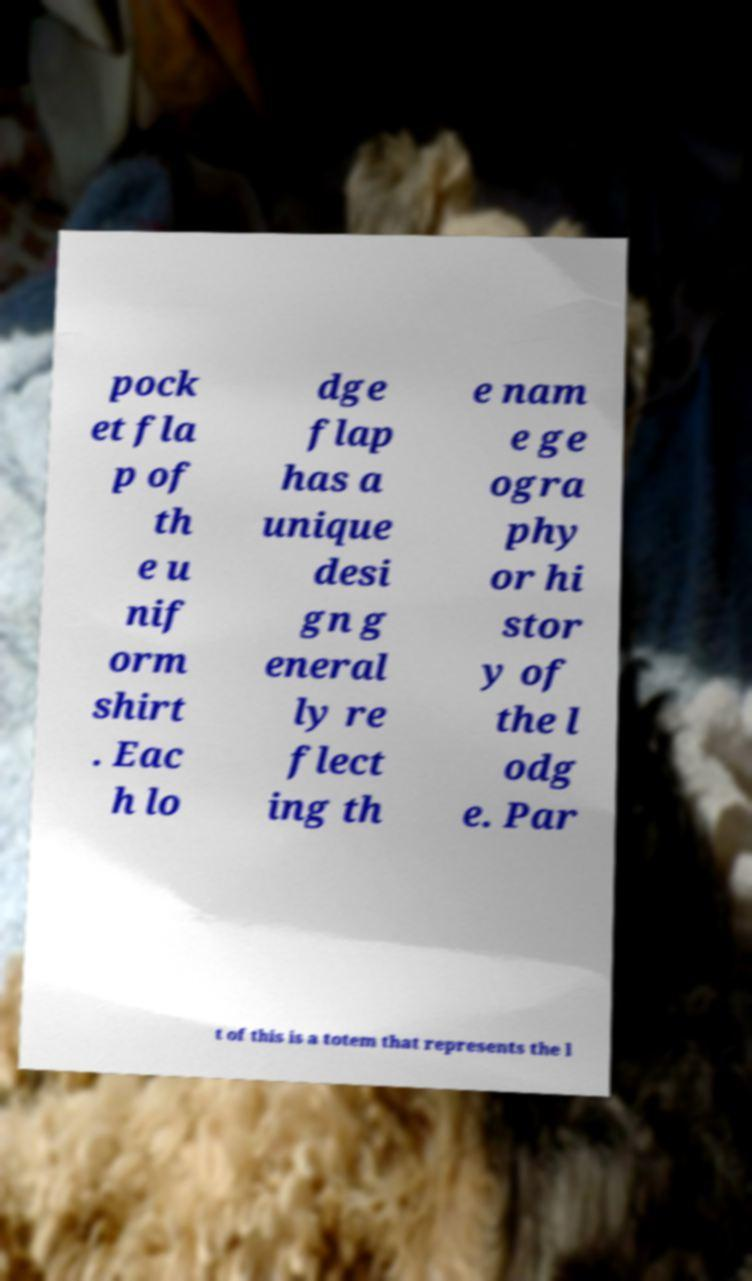Please identify and transcribe the text found in this image. pock et fla p of th e u nif orm shirt . Eac h lo dge flap has a unique desi gn g eneral ly re flect ing th e nam e ge ogra phy or hi stor y of the l odg e. Par t of this is a totem that represents the l 